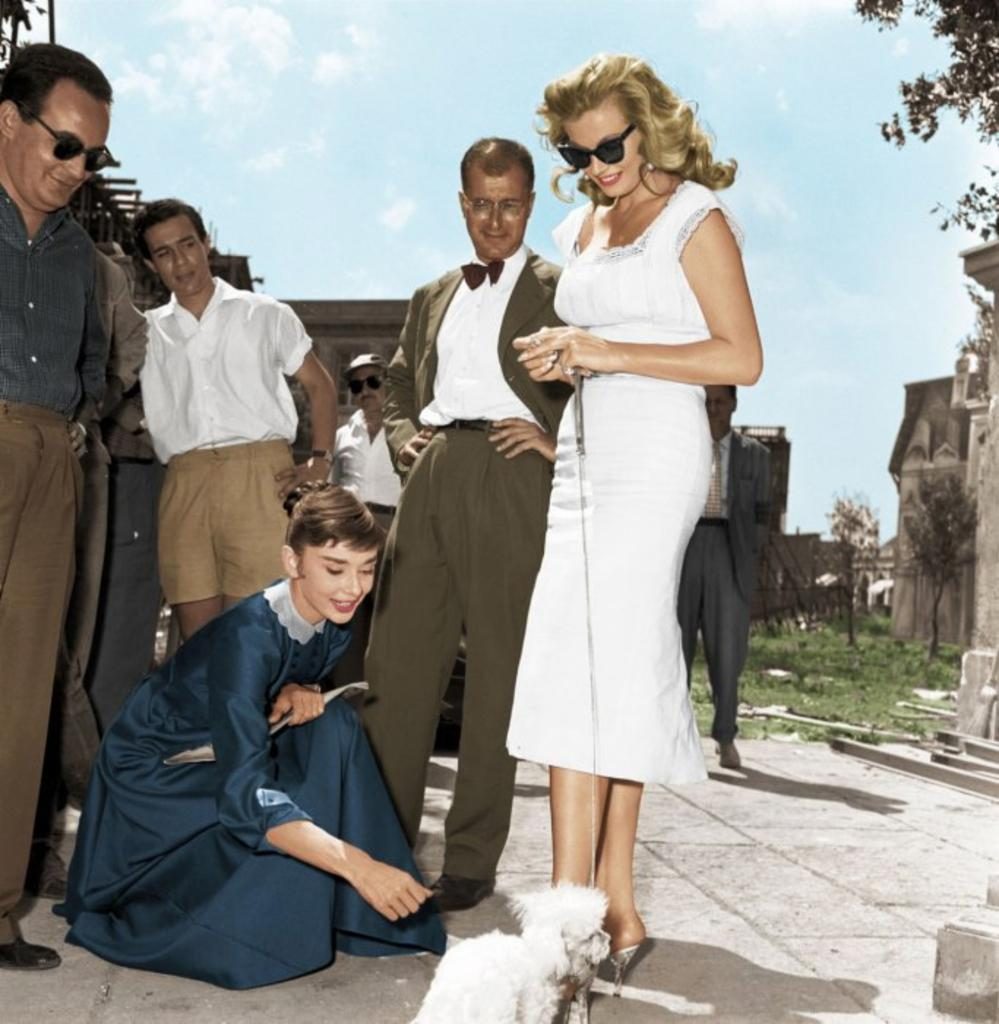How many people are in the image? There is a group of people in the image, but the exact number cannot be determined from the provided facts. What type of animal is on the ground in the image? The facts do not specify the type of animal on the ground in the image. What can be seen in the background of the image? There are buildings, trees, and the sky visible in the background of the image. Can you see a crown on the head of any of the people in the image? There is no mention of a crown in the image, so it cannot be determined if any of the people are wearing one. What type of pen is being used by the animal in the image? There is no pen present in the image, as it features a group of people and an animal on the ground. 